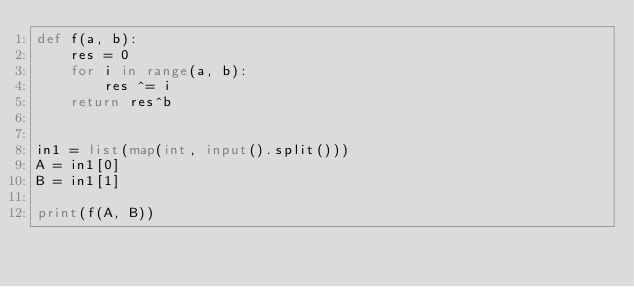Convert code to text. <code><loc_0><loc_0><loc_500><loc_500><_Python_>def f(a, b):
    res = 0
    for i in range(a, b):
        res ^= i
    return res^b


in1 = list(map(int, input().split()))
A = in1[0]
B = in1[1]

print(f(A, B))
</code> 